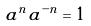<formula> <loc_0><loc_0><loc_500><loc_500>a ^ { n } a ^ { - n } = 1</formula> 